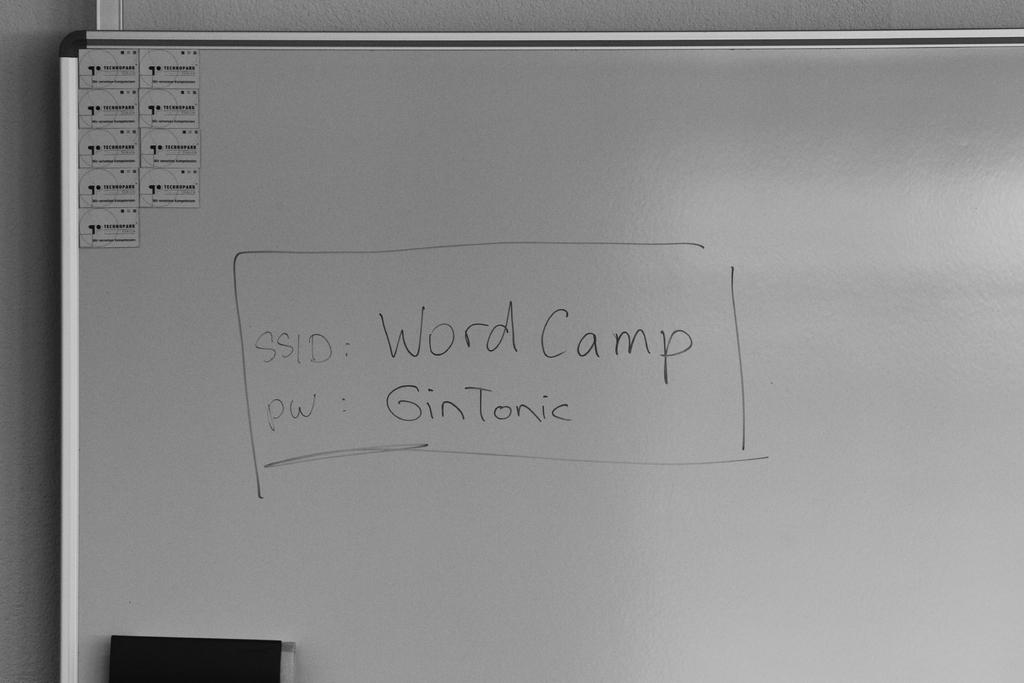<image>
Describe the image concisely. A whiteboard displays an SSID and password for an account. 